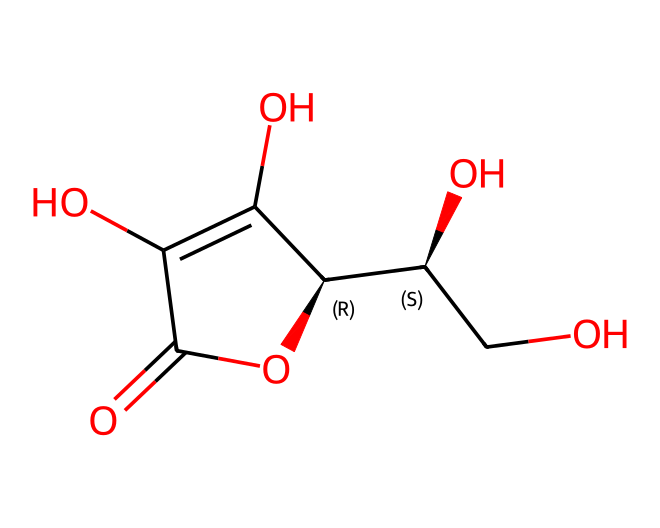What is the molecular formula of ascorbic acid? By analyzing the chemical structure given in the SMILES representation, the constituents include carbon (C), hydrogen (H), and oxygen (O). Counting the atoms, we see it has 6 carbons, 8 hydrogens, and 6 oxygens. Thus, the molecular formula is determined as C6H8O6.
Answer: C6H8O6 How many chiral centers does ascorbic acid have? Looking at the structure, chiral centers are typically indicated by carbon atoms bonded to four different substituents. In this compound, there are two carbon atoms that meet this criterion, therefore ascorbic acid has two chiral centers.
Answer: 2 What type of chemical structure is ascorbic acid classified as? Analyzing the functional groups present in the structure, ascorbic acid contains hydroxyl (–OH) groups and a carbonyl (C=O) group, which classifies it under polyhydroxy compounds, specifically as a carbohydrate derivation.
Answer: carbohydrate What are the possible oxidation states of the carbon atoms in ascorbic acid? By examining the bonding and the presence of various functional groups, we can infer the oxidation state of each carbon. The oxidation states of the carbon atoms range generally from -1 to +4 in this structure, depending on their bonding with other atoms.
Answer: -1 to +4 How does ascorbic acid act as an antioxidant? The presence of hydroxyl and carbonyl groups in the structure allows ascorbic acid to donate electrons to free radicals, hence preventing oxidative damage. The molecular structure plays a crucial role in its ability to stabilize and neutralize these radicals.
Answer: donating electrons What is the primary role of ascorbic acid in military rations? Ascorbic acid is included primarily for its property to prevent oxidation of other nutrients and maintain their potency which is critical in long-term storage of military rations.
Answer: preservation 